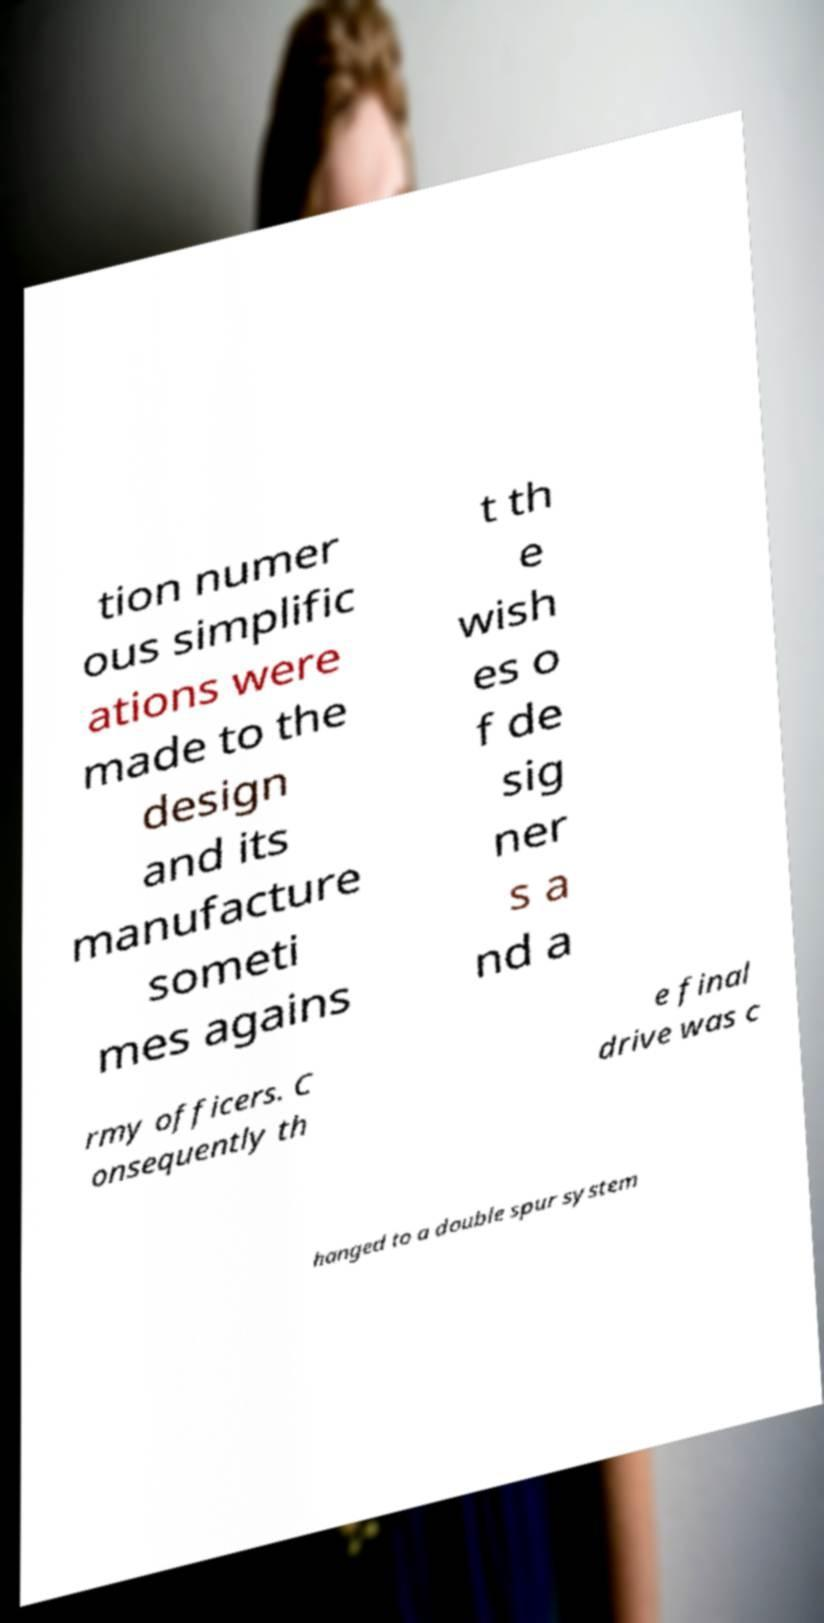I need the written content from this picture converted into text. Can you do that? tion numer ous simplific ations were made to the design and its manufacture someti mes agains t th e wish es o f de sig ner s a nd a rmy officers. C onsequently th e final drive was c hanged to a double spur system 